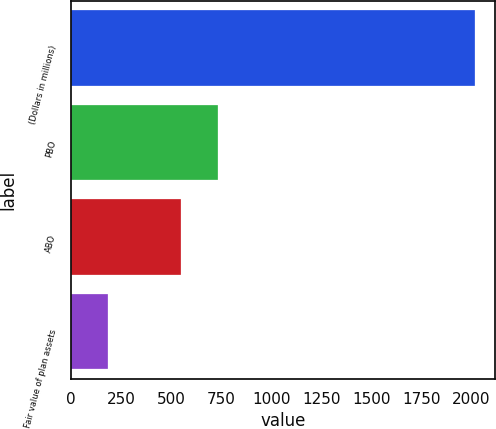Convert chart to OTSL. <chart><loc_0><loc_0><loc_500><loc_500><bar_chart><fcel>(Dollars in millions)<fcel>PBO<fcel>ABO<fcel>Fair value of plan assets<nl><fcel>2015<fcel>734.2<fcel>551<fcel>183<nl></chart> 